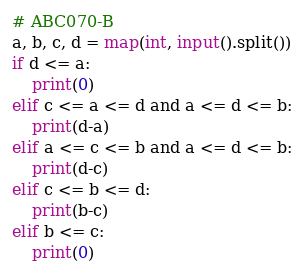Convert code to text. <code><loc_0><loc_0><loc_500><loc_500><_Python_># ABC070-B
a, b, c, d = map(int, input().split())
if d <= a:
    print(0)
elif c <= a <= d and a <= d <= b:
    print(d-a)
elif a <= c <= b and a <= d <= b:
    print(d-c)
elif c <= b <= d:
    print(b-c)
elif b <= c:
    print(0)</code> 